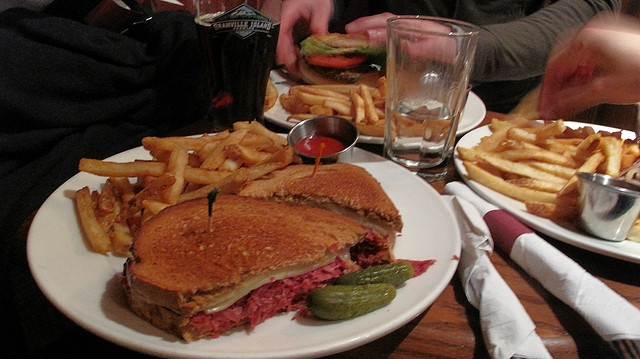Describe the objects in this image and their specific colors. I can see people in black, maroon, brown, and gray tones, sandwich in black, maroon, and brown tones, cup in black, gray, brown, and maroon tones, dining table in black, maroon, and brown tones, and people in black, brown, and maroon tones in this image. 